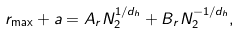Convert formula to latex. <formula><loc_0><loc_0><loc_500><loc_500>r _ { \max } + a = A _ { r } N _ { 2 } ^ { 1 / d _ { h } } + B _ { r } N _ { 2 } ^ { - 1 / d _ { h } } ,</formula> 